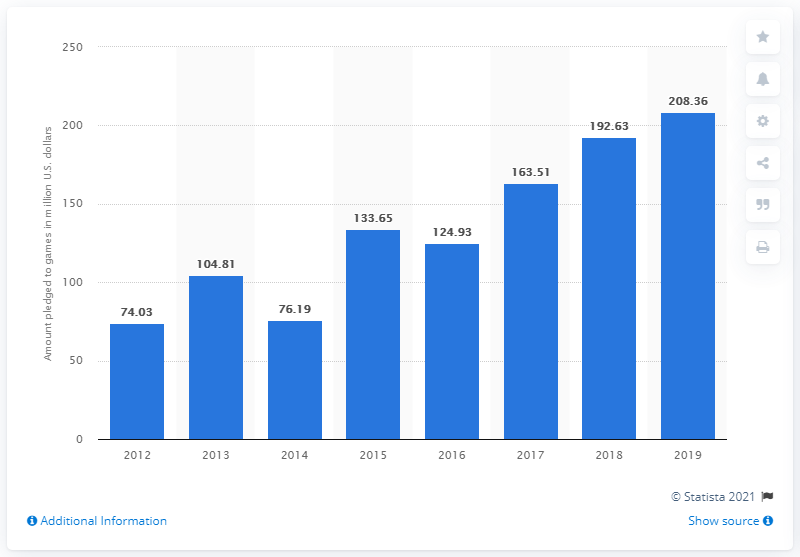Point out several critical features in this image. In 2019, a total of 208.36 million dollars was pledged to Kickstarter. 